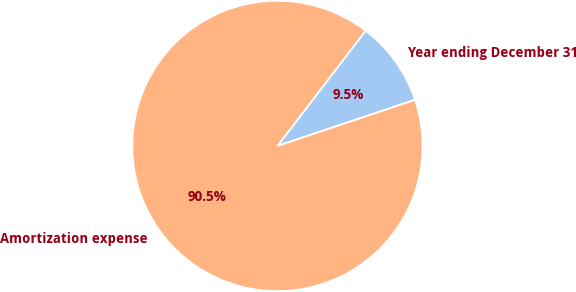Convert chart to OTSL. <chart><loc_0><loc_0><loc_500><loc_500><pie_chart><fcel>Year ending December 31<fcel>Amortization expense<nl><fcel>9.46%<fcel>90.54%<nl></chart> 